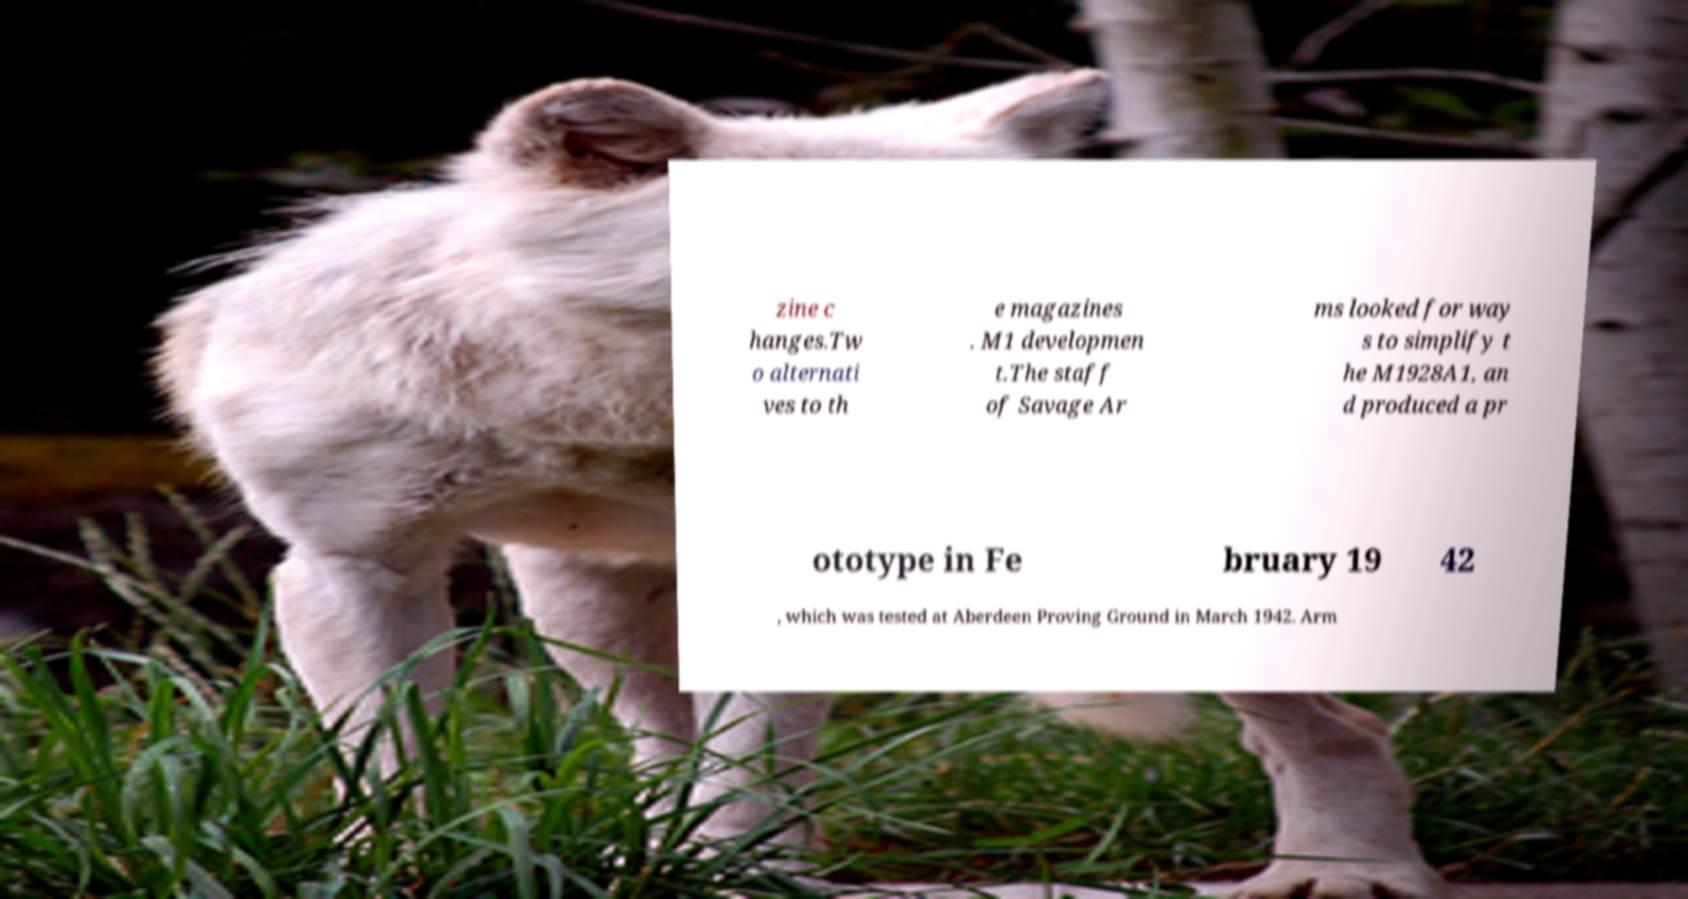There's text embedded in this image that I need extracted. Can you transcribe it verbatim? zine c hanges.Tw o alternati ves to th e magazines . M1 developmen t.The staff of Savage Ar ms looked for way s to simplify t he M1928A1, an d produced a pr ototype in Fe bruary 19 42 , which was tested at Aberdeen Proving Ground in March 1942. Arm 